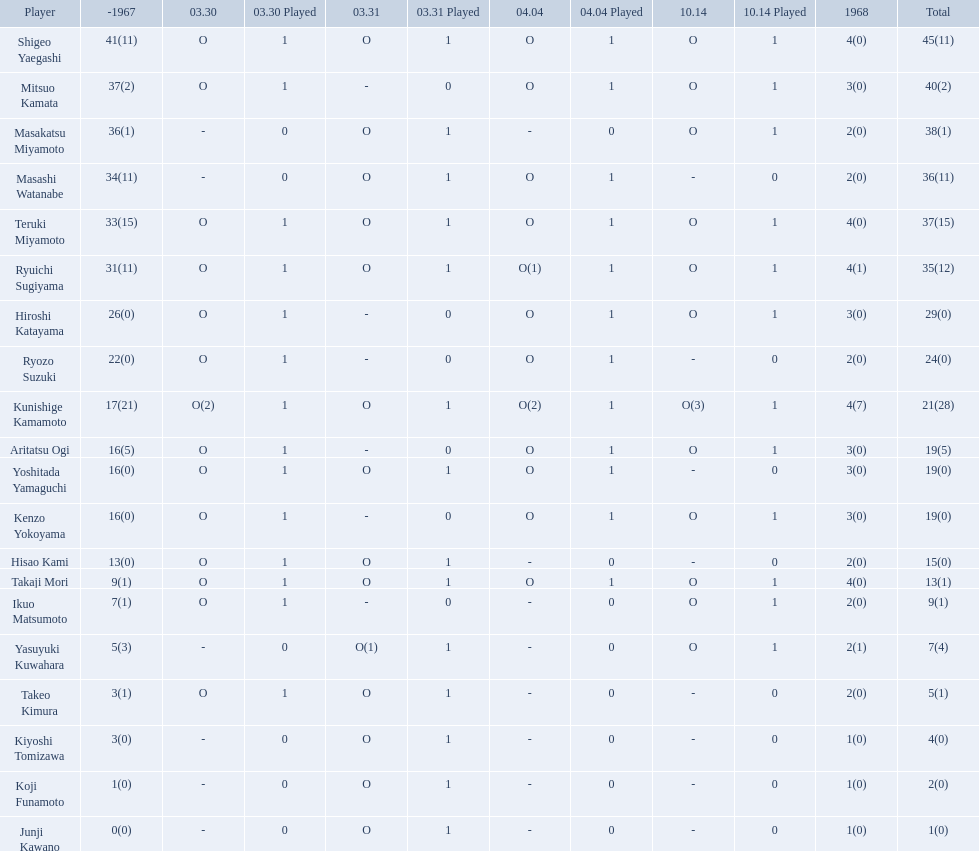Who were the players in the 1968 japanese football? Shigeo Yaegashi, Mitsuo Kamata, Masakatsu Miyamoto, Masashi Watanabe, Teruki Miyamoto, Ryuichi Sugiyama, Hiroshi Katayama, Ryozo Suzuki, Kunishige Kamamoto, Aritatsu Ogi, Yoshitada Yamaguchi, Kenzo Yokoyama, Hisao Kami, Takaji Mori, Ikuo Matsumoto, Yasuyuki Kuwahara, Takeo Kimura, Kiyoshi Tomizawa, Koji Funamoto, Junji Kawano. How many points total did takaji mori have? 13(1). How many points total did junju kawano? 1(0). Who had more points? Takaji Mori. Who are all of the players? Shigeo Yaegashi, Mitsuo Kamata, Masakatsu Miyamoto, Masashi Watanabe, Teruki Miyamoto, Ryuichi Sugiyama, Hiroshi Katayama, Ryozo Suzuki, Kunishige Kamamoto, Aritatsu Ogi, Yoshitada Yamaguchi, Kenzo Yokoyama, Hisao Kami, Takaji Mori, Ikuo Matsumoto, Yasuyuki Kuwahara, Takeo Kimura, Kiyoshi Tomizawa, Koji Funamoto, Junji Kawano. How many points did they receive? 45(11), 40(2), 38(1), 36(11), 37(15), 35(12), 29(0), 24(0), 21(28), 19(5), 19(0), 19(0), 15(0), 13(1), 9(1), 7(4), 5(1), 4(0), 2(0), 1(0). What about just takaji mori and junji kawano? 13(1), 1(0). Of the two, who had more points? Takaji Mori. 